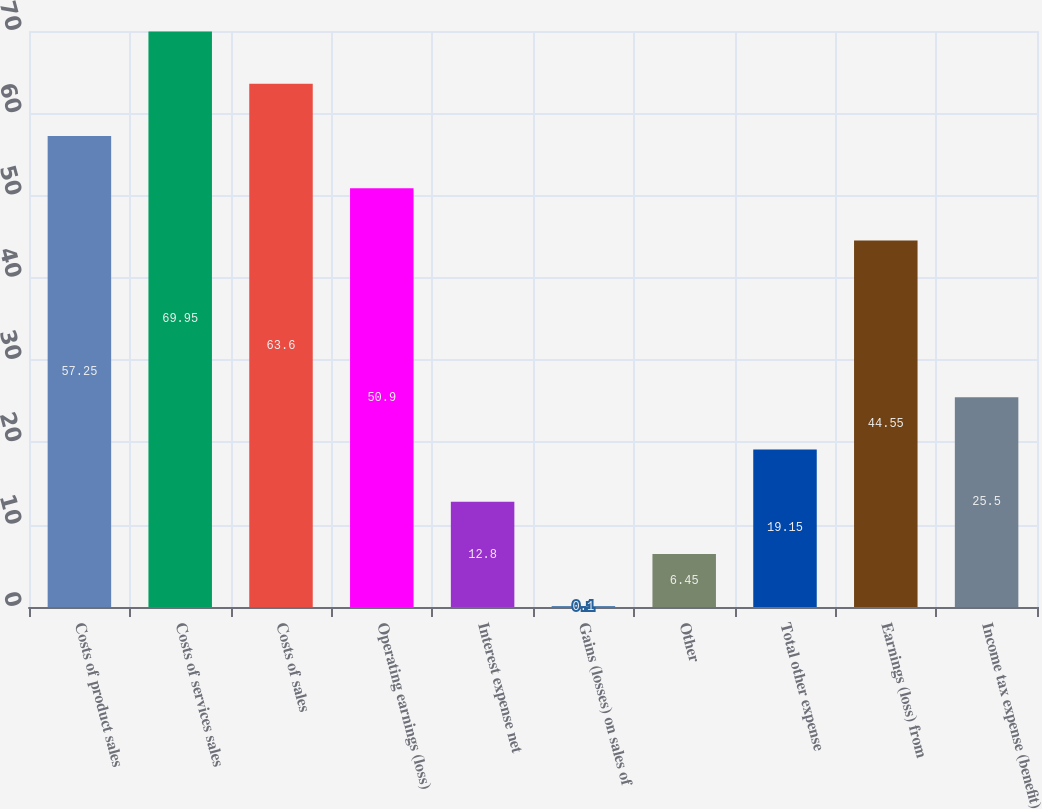Convert chart. <chart><loc_0><loc_0><loc_500><loc_500><bar_chart><fcel>Costs of product sales<fcel>Costs of services sales<fcel>Costs of sales<fcel>Operating earnings (loss)<fcel>Interest expense net<fcel>Gains (losses) on sales of<fcel>Other<fcel>Total other expense<fcel>Earnings (loss) from<fcel>Income tax expense (benefit)<nl><fcel>57.25<fcel>69.95<fcel>63.6<fcel>50.9<fcel>12.8<fcel>0.1<fcel>6.45<fcel>19.15<fcel>44.55<fcel>25.5<nl></chart> 